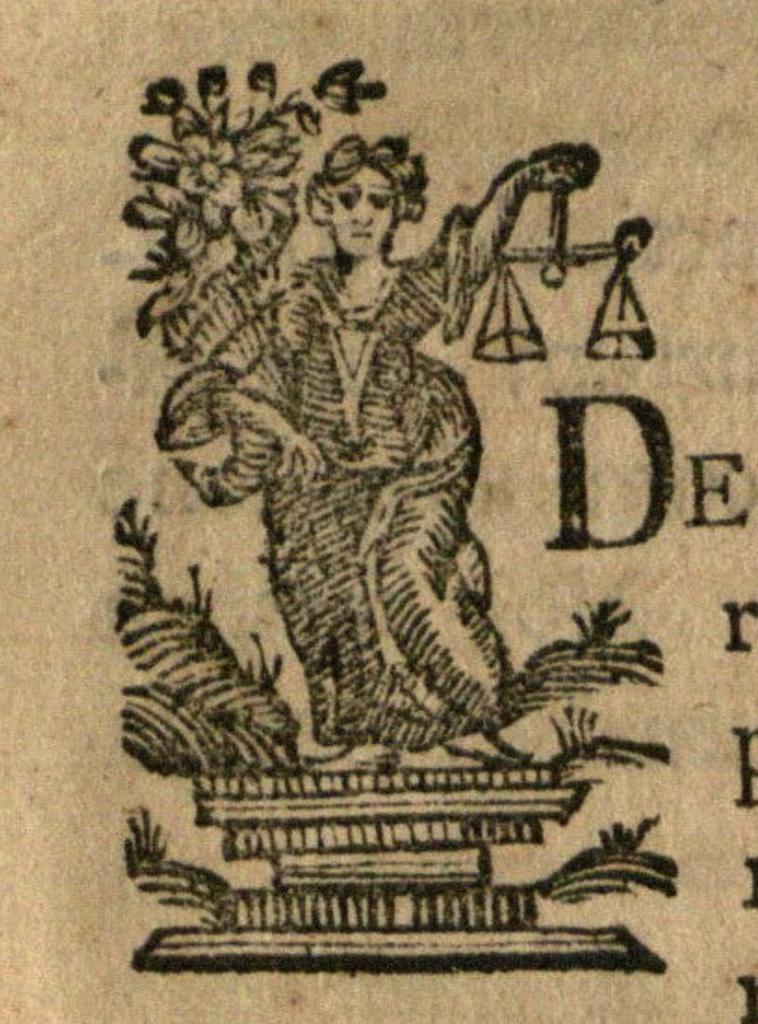<image>
Give a short and clear explanation of the subsequent image. A picture of a woman holding scales of justice shows the letters DE. 